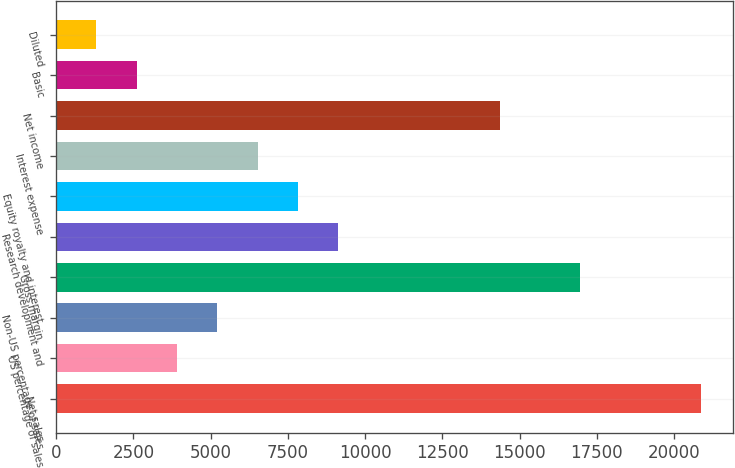<chart> <loc_0><loc_0><loc_500><loc_500><bar_chart><fcel>Net sales<fcel>US percentage of sales<fcel>Non-US percentage of sales<fcel>Gross margin<fcel>Research development and<fcel>Equity royalty and interest<fcel>Interest expense<fcel>Net income<fcel>Basic<fcel>Diluted<nl><fcel>20876.6<fcel>3914.71<fcel>5219.47<fcel>16962.3<fcel>9133.75<fcel>7828.99<fcel>6524.23<fcel>14352.8<fcel>2609.95<fcel>1305.19<nl></chart> 